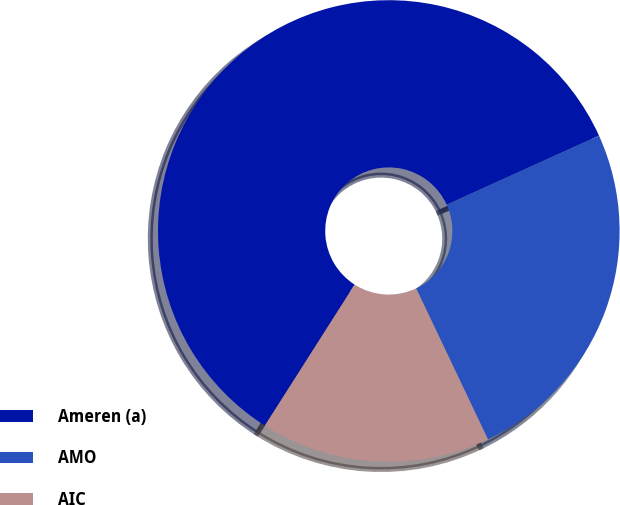Convert chart to OTSL. <chart><loc_0><loc_0><loc_500><loc_500><pie_chart><fcel>Ameren (a)<fcel>AMO<fcel>AIC<nl><fcel>59.2%<fcel>24.71%<fcel>16.09%<nl></chart> 